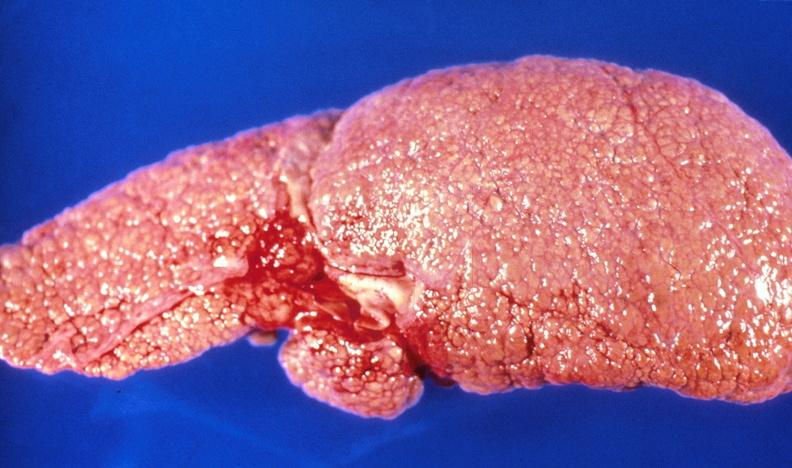what is present?
Answer the question using a single word or phrase. Hepatobiliary 